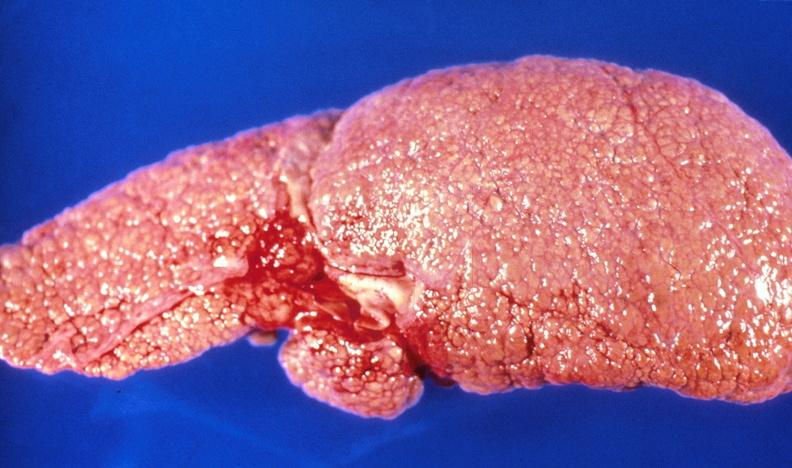what is present?
Answer the question using a single word or phrase. Hepatobiliary 